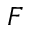Convert formula to latex. <formula><loc_0><loc_0><loc_500><loc_500>F</formula> 